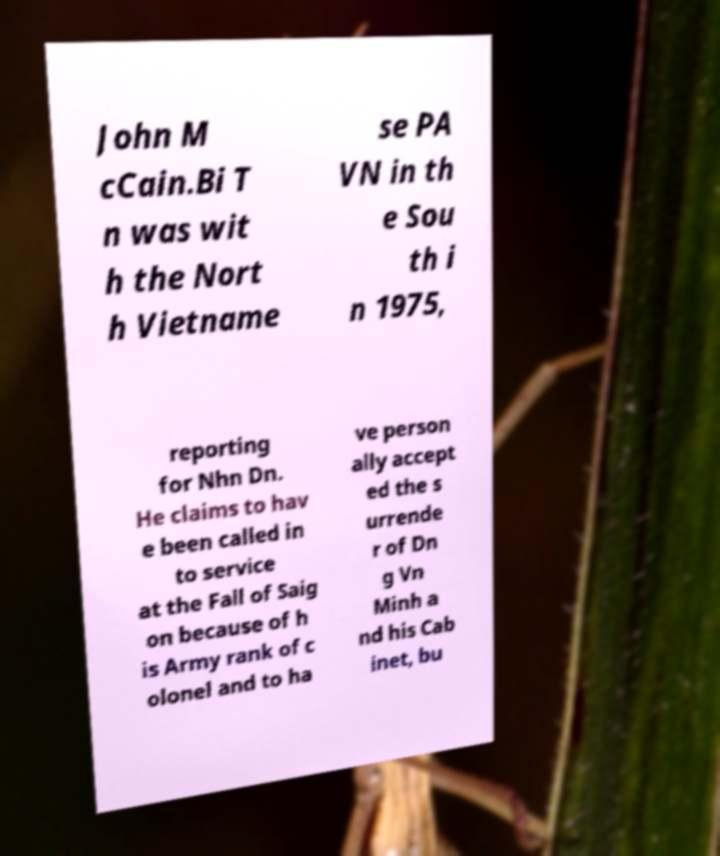There's text embedded in this image that I need extracted. Can you transcribe it verbatim? John M cCain.Bi T n was wit h the Nort h Vietname se PA VN in th e Sou th i n 1975, reporting for Nhn Dn. He claims to hav e been called in to service at the Fall of Saig on because of h is Army rank of c olonel and to ha ve person ally accept ed the s urrende r of Dn g Vn Minh a nd his Cab inet, bu 